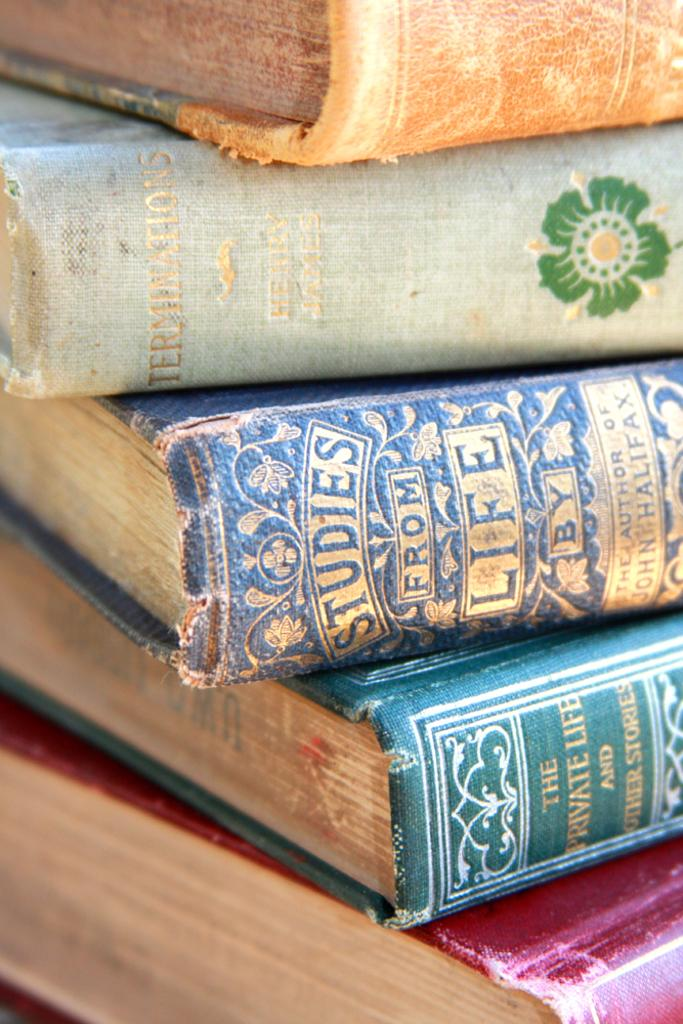<image>
Provide a brief description of the given image. Books stacked on top of one another with one called "Studies From Life". 